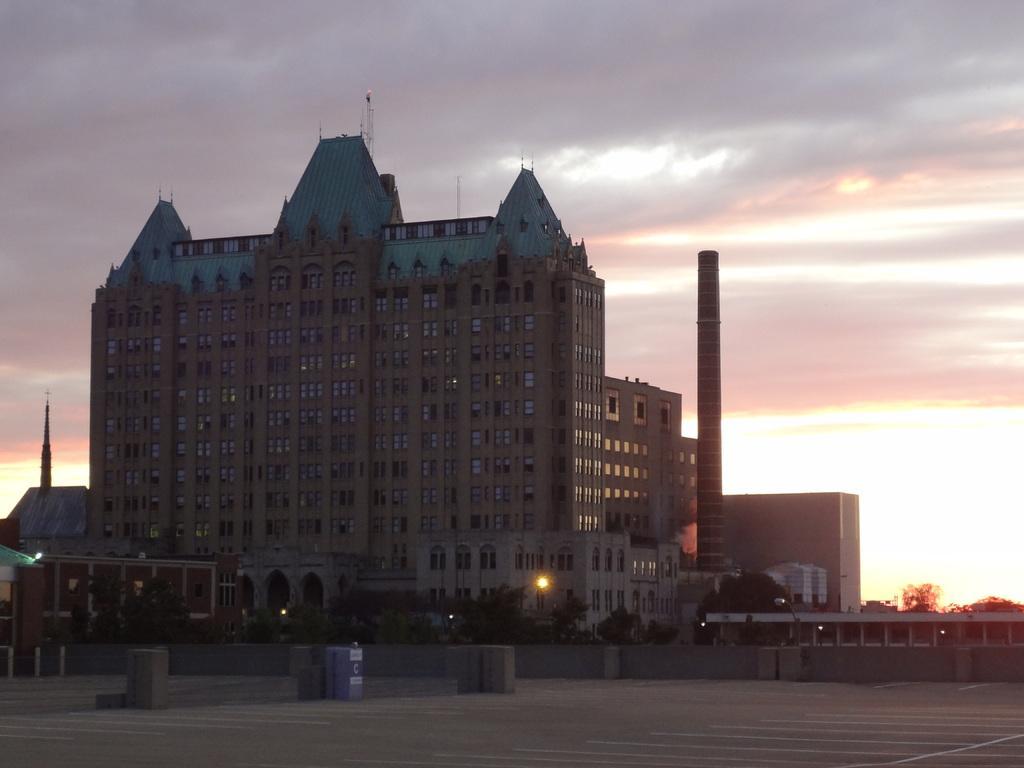Describe this image in one or two sentences. In this picture there is a big brown building with many windows. Beside there is a pipe pole. In the front bottom area there are some trees and a open area. 